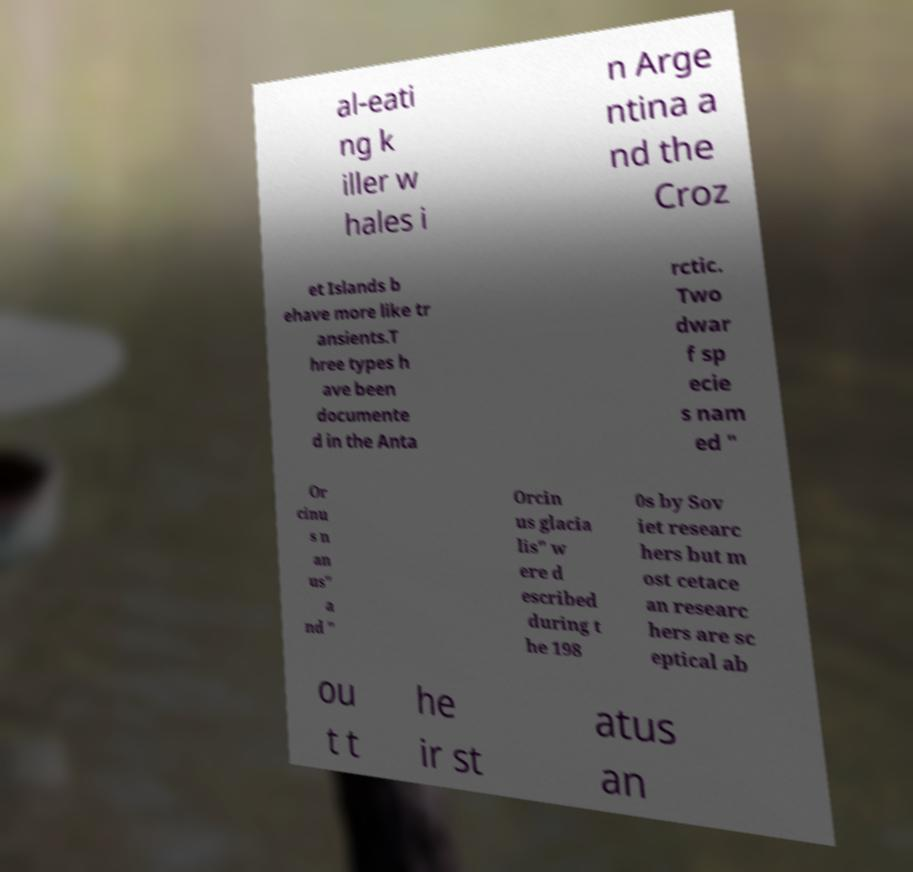There's text embedded in this image that I need extracted. Can you transcribe it verbatim? al-eati ng k iller w hales i n Arge ntina a nd the Croz et Islands b ehave more like tr ansients.T hree types h ave been documente d in the Anta rctic. Two dwar f sp ecie s nam ed " Or cinu s n an us" a nd " Orcin us glacia lis" w ere d escribed during t he 198 0s by Sov iet researc hers but m ost cetace an researc hers are sc eptical ab ou t t he ir st atus an 